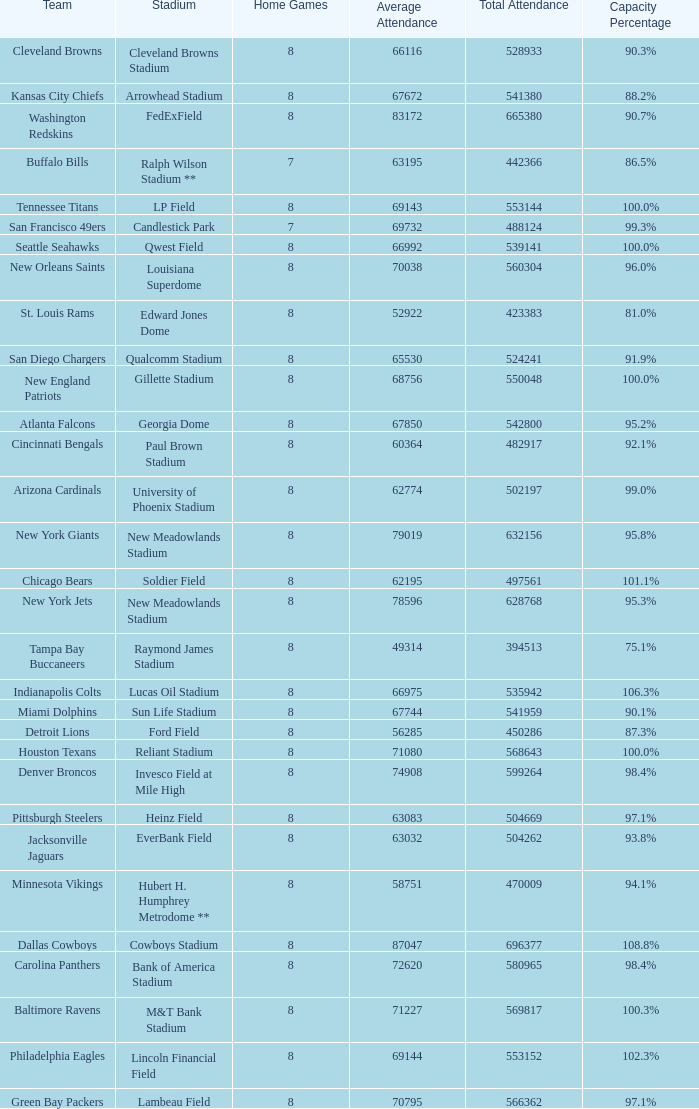What team had a capacity of 102.3%? Philadelphia Eagles. 